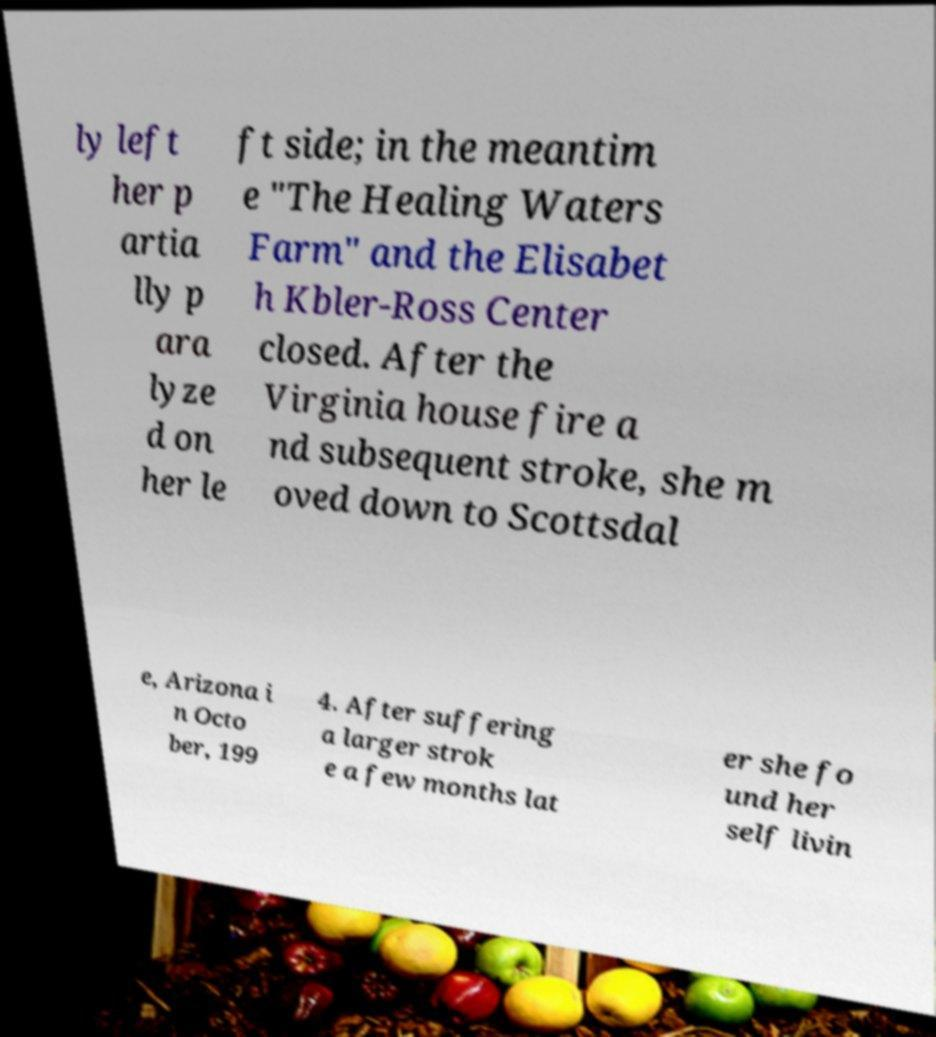Could you extract and type out the text from this image? ly left her p artia lly p ara lyze d on her le ft side; in the meantim e "The Healing Waters Farm" and the Elisabet h Kbler-Ross Center closed. After the Virginia house fire a nd subsequent stroke, she m oved down to Scottsdal e, Arizona i n Octo ber, 199 4. After suffering a larger strok e a few months lat er she fo und her self livin 